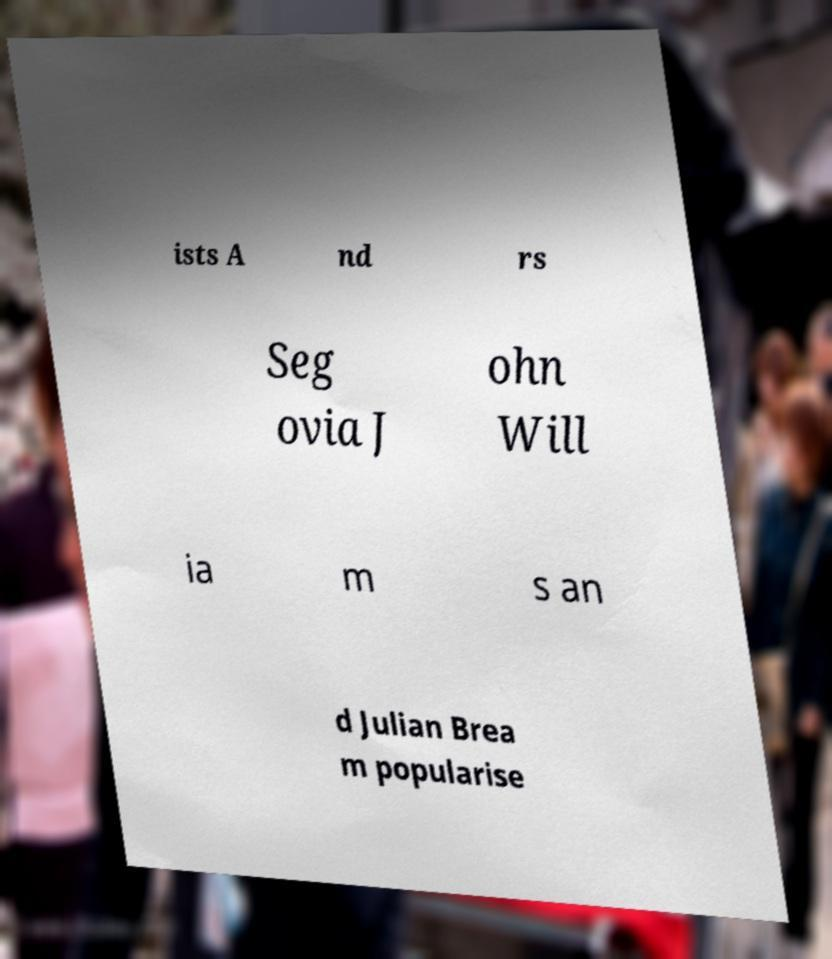I need the written content from this picture converted into text. Can you do that? ists A nd rs Seg ovia J ohn Will ia m s an d Julian Brea m popularise 